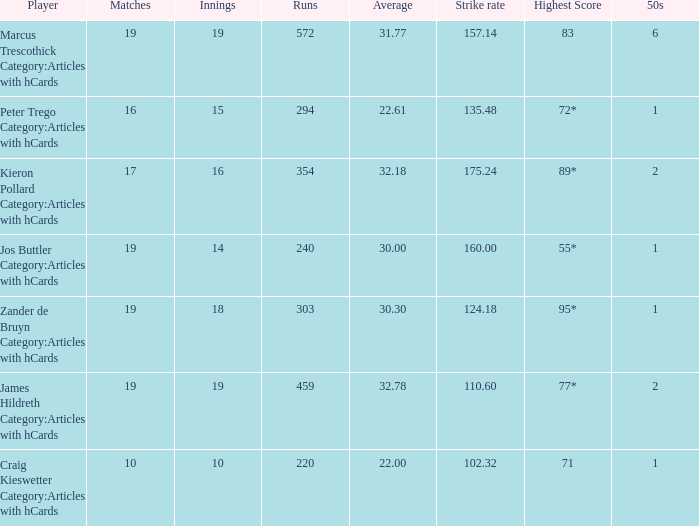What is the top score for the player with a mean of 3 55*. 